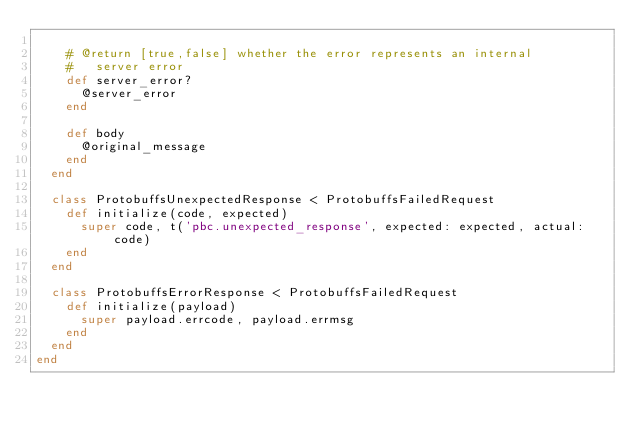Convert code to text. <code><loc_0><loc_0><loc_500><loc_500><_Ruby_>
    # @return [true,false] whether the error represents an internal
    #   server error
    def server_error?
      @server_error
    end

    def body
      @original_message
    end
  end

  class ProtobuffsUnexpectedResponse < ProtobuffsFailedRequest
    def initialize(code, expected)
      super code, t('pbc.unexpected_response', expected: expected, actual: code)
    end
  end

  class ProtobuffsErrorResponse < ProtobuffsFailedRequest
    def initialize(payload)
      super payload.errcode, payload.errmsg
    end
  end
end
</code> 